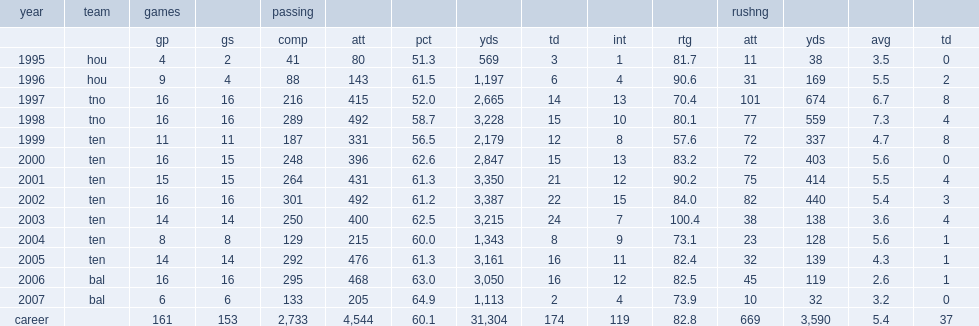Could you parse the entire table as a dict? {'header': ['year', 'team', 'games', '', 'passing', '', '', '', '', '', '', 'rushng', '', '', ''], 'rows': [['', '', 'gp', 'gs', 'comp', 'att', 'pct', 'yds', 'td', 'int', 'rtg', 'att', 'yds', 'avg', 'td'], ['1995', 'hou', '4', '2', '41', '80', '51.3', '569', '3', '1', '81.7', '11', '38', '3.5', '0'], ['1996', 'hou', '9', '4', '88', '143', '61.5', '1,197', '6', '4', '90.6', '31', '169', '5.5', '2'], ['1997', 'tno', '16', '16', '216', '415', '52.0', '2,665', '14', '13', '70.4', '101', '674', '6.7', '8'], ['1998', 'tno', '16', '16', '289', '492', '58.7', '3,228', '15', '10', '80.1', '77', '559', '7.3', '4'], ['1999', 'ten', '11', '11', '187', '331', '56.5', '2,179', '12', '8', '57.6', '72', '337', '4.7', '8'], ['2000', 'ten', '16', '15', '248', '396', '62.6', '2,847', '15', '13', '83.2', '72', '403', '5.6', '0'], ['2001', 'ten', '15', '15', '264', '431', '61.3', '3,350', '21', '12', '90.2', '75', '414', '5.5', '4'], ['2002', 'ten', '16', '16', '301', '492', '61.2', '3,387', '22', '15', '84.0', '82', '440', '5.4', '3'], ['2003', 'ten', '14', '14', '250', '400', '62.5', '3,215', '24', '7', '100.4', '38', '138', '3.6', '4'], ['2004', 'ten', '8', '8', '129', '215', '60.0', '1,343', '8', '9', '73.1', '23', '128', '5.6', '1'], ['2005', 'ten', '14', '14', '292', '476', '61.3', '3,161', '16', '11', '82.4', '32', '139', '4.3', '1'], ['2006', 'bal', '16', '16', '295', '468', '63.0', '3,050', '16', '12', '82.5', '45', '119', '2.6', '1'], ['2007', 'bal', '6', '6', '133', '205', '64.9', '1,113', '2', '4', '73.9', '10', '32', '3.2', '0'], ['career', '', '161', '153', '2,733', '4,544', '60.1', '31,304', '174', '119', '82.8', '669', '3,590', '5.4', '37']]} When did mcnair finish with 492 attempts, 289 completions, 3,228 yards and 15 touchdowns? 1998.0. 